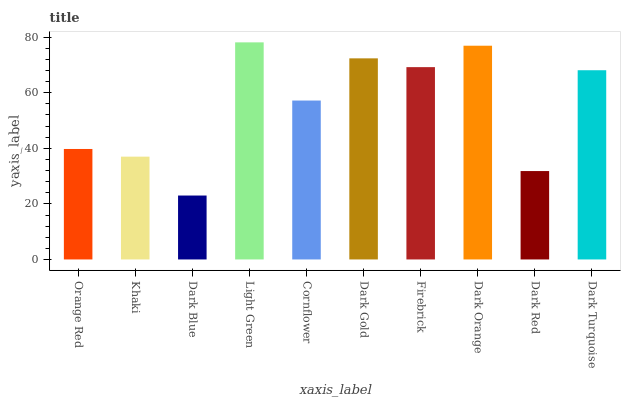Is Khaki the minimum?
Answer yes or no. No. Is Khaki the maximum?
Answer yes or no. No. Is Orange Red greater than Khaki?
Answer yes or no. Yes. Is Khaki less than Orange Red?
Answer yes or no. Yes. Is Khaki greater than Orange Red?
Answer yes or no. No. Is Orange Red less than Khaki?
Answer yes or no. No. Is Dark Turquoise the high median?
Answer yes or no. Yes. Is Cornflower the low median?
Answer yes or no. Yes. Is Dark Red the high median?
Answer yes or no. No. Is Orange Red the low median?
Answer yes or no. No. 